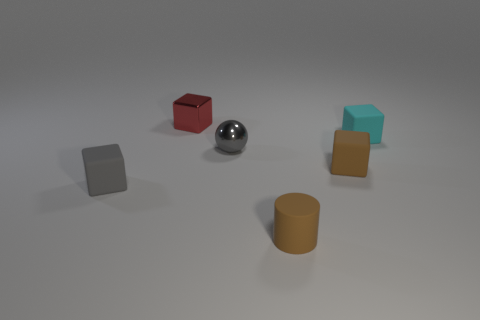How many tiny cubes are both on the right side of the brown cylinder and behind the cyan block?
Make the answer very short. 0. How many objects are either small red shiny blocks or objects behind the tiny sphere?
Offer a terse response. 2. What is the shape of the small thing that is the same color as the rubber cylinder?
Ensure brevity in your answer.  Cube. There is a shiny thing behind the small shiny sphere; what color is it?
Ensure brevity in your answer.  Red. What number of things are either tiny metal things that are on the left side of the small ball or yellow matte spheres?
Offer a very short reply. 1. The cylinder that is the same size as the gray shiny ball is what color?
Offer a very short reply. Brown. Are there more small cyan cubes on the right side of the tiny gray metallic sphere than blue cubes?
Give a very brief answer. Yes. What is the block that is left of the brown cylinder and to the right of the tiny gray block made of?
Ensure brevity in your answer.  Metal. There is a cube that is in front of the brown matte cube; does it have the same color as the small metal thing that is on the right side of the tiny red metal object?
Keep it short and to the point. Yes. How many other things are the same size as the red object?
Your answer should be compact. 5. 